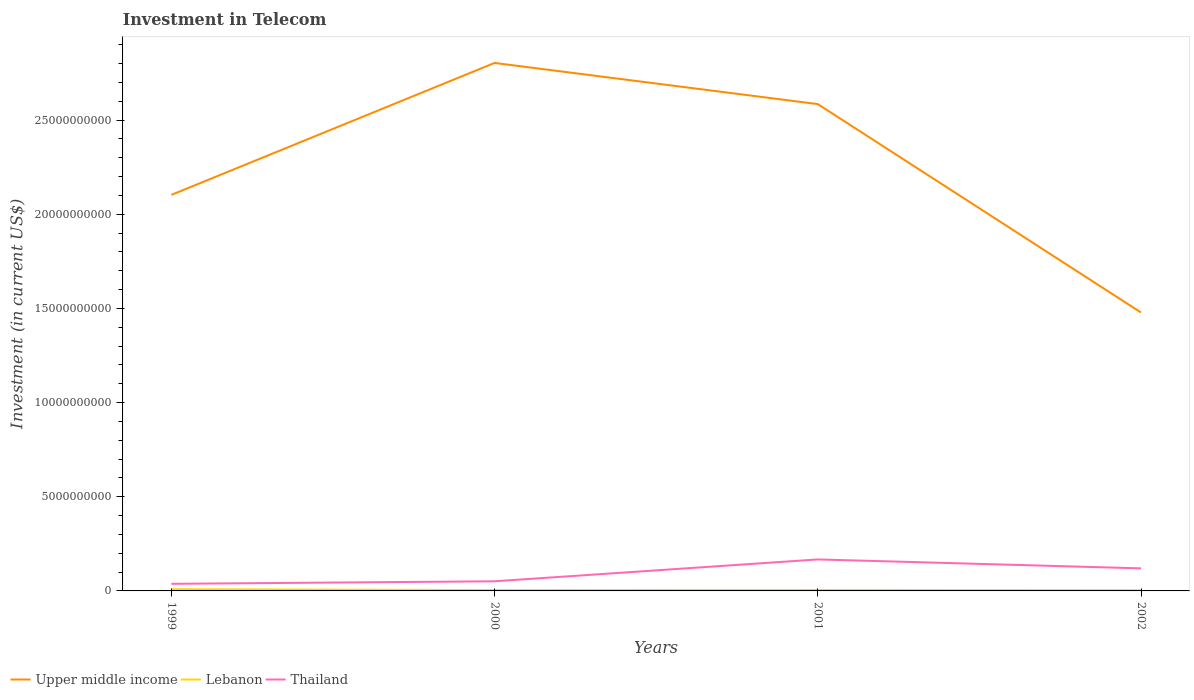How many different coloured lines are there?
Make the answer very short. 3. Does the line corresponding to Lebanon intersect with the line corresponding to Upper middle income?
Your answer should be compact. No. Is the number of lines equal to the number of legend labels?
Provide a short and direct response. Yes. Across all years, what is the maximum amount invested in telecom in Lebanon?
Ensure brevity in your answer.  3.79e+07. In which year was the amount invested in telecom in Lebanon maximum?
Keep it short and to the point. 2002. What is the total amount invested in telecom in Upper middle income in the graph?
Keep it short and to the point. -7.00e+09. What is the difference between the highest and the second highest amount invested in telecom in Lebanon?
Keep it short and to the point. 5.51e+07. How many lines are there?
Offer a terse response. 3. How many years are there in the graph?
Offer a terse response. 4. What is the difference between two consecutive major ticks on the Y-axis?
Ensure brevity in your answer.  5.00e+09. Does the graph contain any zero values?
Ensure brevity in your answer.  No. Does the graph contain grids?
Ensure brevity in your answer.  No. Where does the legend appear in the graph?
Provide a short and direct response. Bottom left. How many legend labels are there?
Provide a short and direct response. 3. What is the title of the graph?
Offer a very short reply. Investment in Telecom. What is the label or title of the Y-axis?
Offer a terse response. Investment (in current US$). What is the Investment (in current US$) in Upper middle income in 1999?
Give a very brief answer. 2.10e+1. What is the Investment (in current US$) of Lebanon in 1999?
Your response must be concise. 9.30e+07. What is the Investment (in current US$) in Thailand in 1999?
Make the answer very short. 3.77e+08. What is the Investment (in current US$) of Upper middle income in 2000?
Your answer should be very brief. 2.80e+1. What is the Investment (in current US$) in Lebanon in 2000?
Provide a short and direct response. 4.64e+07. What is the Investment (in current US$) of Thailand in 2000?
Your response must be concise. 5.11e+08. What is the Investment (in current US$) in Upper middle income in 2001?
Offer a terse response. 2.58e+1. What is the Investment (in current US$) of Lebanon in 2001?
Make the answer very short. 5.38e+07. What is the Investment (in current US$) in Thailand in 2001?
Your answer should be very brief. 1.67e+09. What is the Investment (in current US$) in Upper middle income in 2002?
Offer a terse response. 1.48e+1. What is the Investment (in current US$) of Lebanon in 2002?
Offer a very short reply. 3.79e+07. What is the Investment (in current US$) in Thailand in 2002?
Ensure brevity in your answer.  1.20e+09. Across all years, what is the maximum Investment (in current US$) in Upper middle income?
Offer a very short reply. 2.80e+1. Across all years, what is the maximum Investment (in current US$) of Lebanon?
Provide a succinct answer. 9.30e+07. Across all years, what is the maximum Investment (in current US$) in Thailand?
Your response must be concise. 1.67e+09. Across all years, what is the minimum Investment (in current US$) in Upper middle income?
Your answer should be very brief. 1.48e+1. Across all years, what is the minimum Investment (in current US$) of Lebanon?
Offer a terse response. 3.79e+07. Across all years, what is the minimum Investment (in current US$) of Thailand?
Provide a short and direct response. 3.77e+08. What is the total Investment (in current US$) of Upper middle income in the graph?
Your answer should be very brief. 8.97e+1. What is the total Investment (in current US$) in Lebanon in the graph?
Give a very brief answer. 2.31e+08. What is the total Investment (in current US$) in Thailand in the graph?
Provide a succinct answer. 3.76e+09. What is the difference between the Investment (in current US$) in Upper middle income in 1999 and that in 2000?
Your answer should be compact. -7.00e+09. What is the difference between the Investment (in current US$) in Lebanon in 1999 and that in 2000?
Your response must be concise. 4.66e+07. What is the difference between the Investment (in current US$) in Thailand in 1999 and that in 2000?
Keep it short and to the point. -1.34e+08. What is the difference between the Investment (in current US$) of Upper middle income in 1999 and that in 2001?
Keep it short and to the point. -4.82e+09. What is the difference between the Investment (in current US$) of Lebanon in 1999 and that in 2001?
Provide a succinct answer. 3.92e+07. What is the difference between the Investment (in current US$) in Thailand in 1999 and that in 2001?
Offer a very short reply. -1.30e+09. What is the difference between the Investment (in current US$) in Upper middle income in 1999 and that in 2002?
Ensure brevity in your answer.  6.25e+09. What is the difference between the Investment (in current US$) of Lebanon in 1999 and that in 2002?
Make the answer very short. 5.51e+07. What is the difference between the Investment (in current US$) in Thailand in 1999 and that in 2002?
Provide a short and direct response. -8.21e+08. What is the difference between the Investment (in current US$) of Upper middle income in 2000 and that in 2001?
Ensure brevity in your answer.  2.18e+09. What is the difference between the Investment (in current US$) of Lebanon in 2000 and that in 2001?
Your answer should be very brief. -7.40e+06. What is the difference between the Investment (in current US$) in Thailand in 2000 and that in 2001?
Offer a very short reply. -1.16e+09. What is the difference between the Investment (in current US$) in Upper middle income in 2000 and that in 2002?
Your answer should be compact. 1.33e+1. What is the difference between the Investment (in current US$) of Lebanon in 2000 and that in 2002?
Keep it short and to the point. 8.50e+06. What is the difference between the Investment (in current US$) in Thailand in 2000 and that in 2002?
Make the answer very short. -6.87e+08. What is the difference between the Investment (in current US$) in Upper middle income in 2001 and that in 2002?
Offer a terse response. 1.11e+1. What is the difference between the Investment (in current US$) of Lebanon in 2001 and that in 2002?
Your response must be concise. 1.59e+07. What is the difference between the Investment (in current US$) in Thailand in 2001 and that in 2002?
Make the answer very short. 4.74e+08. What is the difference between the Investment (in current US$) of Upper middle income in 1999 and the Investment (in current US$) of Lebanon in 2000?
Offer a terse response. 2.10e+1. What is the difference between the Investment (in current US$) in Upper middle income in 1999 and the Investment (in current US$) in Thailand in 2000?
Make the answer very short. 2.05e+1. What is the difference between the Investment (in current US$) in Lebanon in 1999 and the Investment (in current US$) in Thailand in 2000?
Provide a short and direct response. -4.18e+08. What is the difference between the Investment (in current US$) of Upper middle income in 1999 and the Investment (in current US$) of Lebanon in 2001?
Your answer should be compact. 2.10e+1. What is the difference between the Investment (in current US$) in Upper middle income in 1999 and the Investment (in current US$) in Thailand in 2001?
Provide a short and direct response. 1.94e+1. What is the difference between the Investment (in current US$) of Lebanon in 1999 and the Investment (in current US$) of Thailand in 2001?
Provide a succinct answer. -1.58e+09. What is the difference between the Investment (in current US$) in Upper middle income in 1999 and the Investment (in current US$) in Lebanon in 2002?
Provide a succinct answer. 2.10e+1. What is the difference between the Investment (in current US$) in Upper middle income in 1999 and the Investment (in current US$) in Thailand in 2002?
Offer a very short reply. 1.98e+1. What is the difference between the Investment (in current US$) in Lebanon in 1999 and the Investment (in current US$) in Thailand in 2002?
Offer a terse response. -1.11e+09. What is the difference between the Investment (in current US$) of Upper middle income in 2000 and the Investment (in current US$) of Lebanon in 2001?
Ensure brevity in your answer.  2.80e+1. What is the difference between the Investment (in current US$) of Upper middle income in 2000 and the Investment (in current US$) of Thailand in 2001?
Provide a succinct answer. 2.64e+1. What is the difference between the Investment (in current US$) of Lebanon in 2000 and the Investment (in current US$) of Thailand in 2001?
Ensure brevity in your answer.  -1.63e+09. What is the difference between the Investment (in current US$) of Upper middle income in 2000 and the Investment (in current US$) of Lebanon in 2002?
Give a very brief answer. 2.80e+1. What is the difference between the Investment (in current US$) of Upper middle income in 2000 and the Investment (in current US$) of Thailand in 2002?
Your response must be concise. 2.68e+1. What is the difference between the Investment (in current US$) in Lebanon in 2000 and the Investment (in current US$) in Thailand in 2002?
Provide a succinct answer. -1.15e+09. What is the difference between the Investment (in current US$) in Upper middle income in 2001 and the Investment (in current US$) in Lebanon in 2002?
Keep it short and to the point. 2.58e+1. What is the difference between the Investment (in current US$) in Upper middle income in 2001 and the Investment (in current US$) in Thailand in 2002?
Make the answer very short. 2.46e+1. What is the difference between the Investment (in current US$) in Lebanon in 2001 and the Investment (in current US$) in Thailand in 2002?
Ensure brevity in your answer.  -1.14e+09. What is the average Investment (in current US$) in Upper middle income per year?
Offer a terse response. 2.24e+1. What is the average Investment (in current US$) in Lebanon per year?
Your response must be concise. 5.78e+07. What is the average Investment (in current US$) in Thailand per year?
Provide a succinct answer. 9.40e+08. In the year 1999, what is the difference between the Investment (in current US$) of Upper middle income and Investment (in current US$) of Lebanon?
Provide a succinct answer. 2.09e+1. In the year 1999, what is the difference between the Investment (in current US$) in Upper middle income and Investment (in current US$) in Thailand?
Offer a very short reply. 2.06e+1. In the year 1999, what is the difference between the Investment (in current US$) in Lebanon and Investment (in current US$) in Thailand?
Your response must be concise. -2.84e+08. In the year 2000, what is the difference between the Investment (in current US$) in Upper middle income and Investment (in current US$) in Lebanon?
Make the answer very short. 2.80e+1. In the year 2000, what is the difference between the Investment (in current US$) in Upper middle income and Investment (in current US$) in Thailand?
Provide a short and direct response. 2.75e+1. In the year 2000, what is the difference between the Investment (in current US$) of Lebanon and Investment (in current US$) of Thailand?
Your answer should be compact. -4.65e+08. In the year 2001, what is the difference between the Investment (in current US$) in Upper middle income and Investment (in current US$) in Lebanon?
Your response must be concise. 2.58e+1. In the year 2001, what is the difference between the Investment (in current US$) of Upper middle income and Investment (in current US$) of Thailand?
Provide a short and direct response. 2.42e+1. In the year 2001, what is the difference between the Investment (in current US$) of Lebanon and Investment (in current US$) of Thailand?
Your answer should be compact. -1.62e+09. In the year 2002, what is the difference between the Investment (in current US$) of Upper middle income and Investment (in current US$) of Lebanon?
Offer a terse response. 1.47e+1. In the year 2002, what is the difference between the Investment (in current US$) in Upper middle income and Investment (in current US$) in Thailand?
Your response must be concise. 1.36e+1. In the year 2002, what is the difference between the Investment (in current US$) in Lebanon and Investment (in current US$) in Thailand?
Your answer should be very brief. -1.16e+09. What is the ratio of the Investment (in current US$) in Upper middle income in 1999 to that in 2000?
Your answer should be compact. 0.75. What is the ratio of the Investment (in current US$) of Lebanon in 1999 to that in 2000?
Offer a very short reply. 2. What is the ratio of the Investment (in current US$) of Thailand in 1999 to that in 2000?
Provide a succinct answer. 0.74. What is the ratio of the Investment (in current US$) of Upper middle income in 1999 to that in 2001?
Provide a succinct answer. 0.81. What is the ratio of the Investment (in current US$) of Lebanon in 1999 to that in 2001?
Give a very brief answer. 1.73. What is the ratio of the Investment (in current US$) in Thailand in 1999 to that in 2001?
Your response must be concise. 0.23. What is the ratio of the Investment (in current US$) in Upper middle income in 1999 to that in 2002?
Make the answer very short. 1.42. What is the ratio of the Investment (in current US$) of Lebanon in 1999 to that in 2002?
Provide a short and direct response. 2.45. What is the ratio of the Investment (in current US$) in Thailand in 1999 to that in 2002?
Provide a succinct answer. 0.31. What is the ratio of the Investment (in current US$) in Upper middle income in 2000 to that in 2001?
Make the answer very short. 1.08. What is the ratio of the Investment (in current US$) in Lebanon in 2000 to that in 2001?
Your response must be concise. 0.86. What is the ratio of the Investment (in current US$) in Thailand in 2000 to that in 2001?
Keep it short and to the point. 0.31. What is the ratio of the Investment (in current US$) of Upper middle income in 2000 to that in 2002?
Your answer should be compact. 1.9. What is the ratio of the Investment (in current US$) of Lebanon in 2000 to that in 2002?
Provide a succinct answer. 1.22. What is the ratio of the Investment (in current US$) in Thailand in 2000 to that in 2002?
Keep it short and to the point. 0.43. What is the ratio of the Investment (in current US$) of Upper middle income in 2001 to that in 2002?
Your answer should be very brief. 1.75. What is the ratio of the Investment (in current US$) in Lebanon in 2001 to that in 2002?
Offer a very short reply. 1.42. What is the ratio of the Investment (in current US$) in Thailand in 2001 to that in 2002?
Make the answer very short. 1.4. What is the difference between the highest and the second highest Investment (in current US$) in Upper middle income?
Provide a short and direct response. 2.18e+09. What is the difference between the highest and the second highest Investment (in current US$) in Lebanon?
Offer a terse response. 3.92e+07. What is the difference between the highest and the second highest Investment (in current US$) of Thailand?
Your answer should be compact. 4.74e+08. What is the difference between the highest and the lowest Investment (in current US$) of Upper middle income?
Make the answer very short. 1.33e+1. What is the difference between the highest and the lowest Investment (in current US$) of Lebanon?
Ensure brevity in your answer.  5.51e+07. What is the difference between the highest and the lowest Investment (in current US$) of Thailand?
Provide a short and direct response. 1.30e+09. 